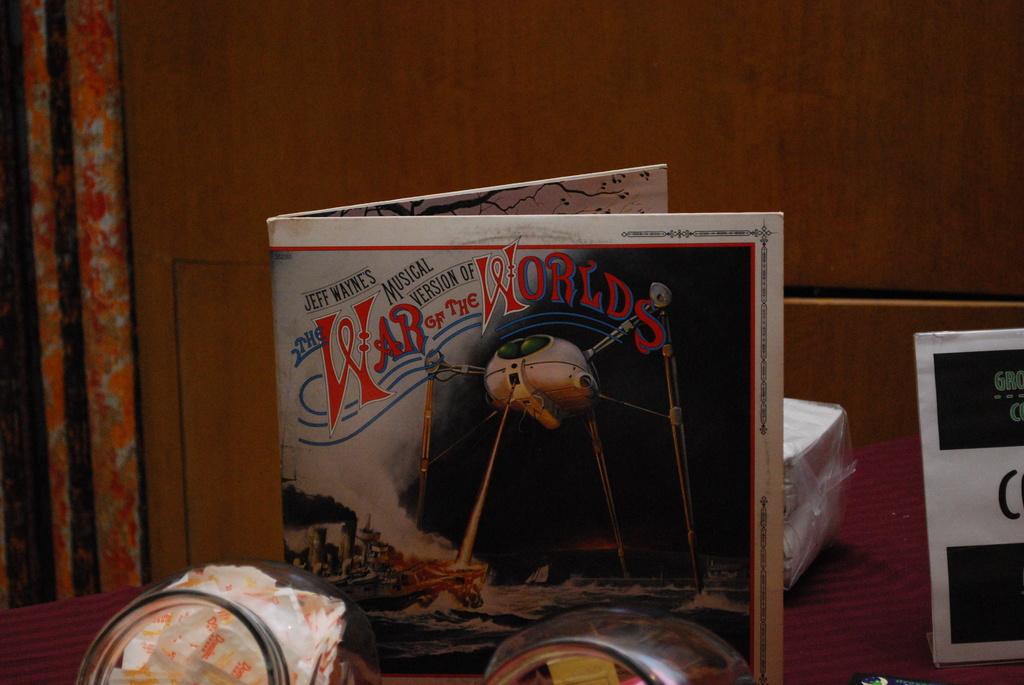What is the title of the open book?
Keep it short and to the point. War of the worlds. Whose musical version is this?
Provide a succinct answer. Jeff wayne's. 